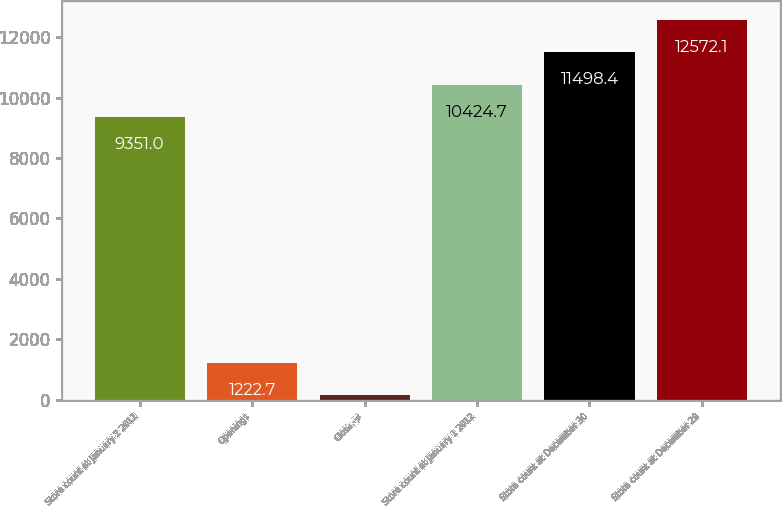Convert chart. <chart><loc_0><loc_0><loc_500><loc_500><bar_chart><fcel>Store count at January 2 2011<fcel>Openings<fcel>Closings<fcel>Store count at January 1 2012<fcel>Store count at December 30<fcel>Store count at December 29<nl><fcel>9351<fcel>1222.7<fcel>149<fcel>10424.7<fcel>11498.4<fcel>12572.1<nl></chart> 